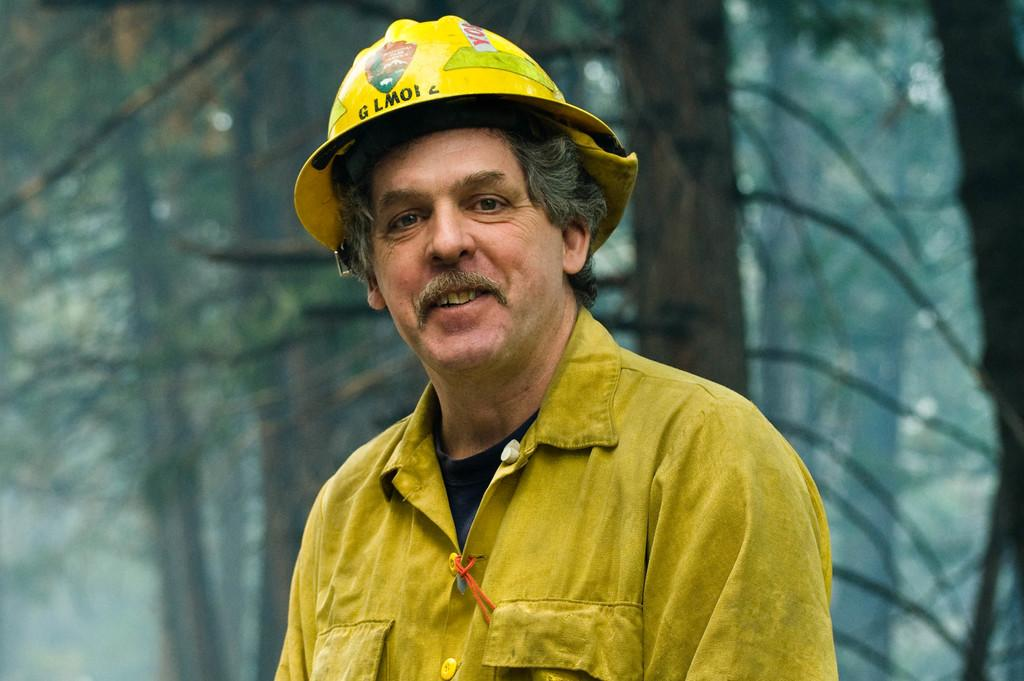What is the main subject of the image? The main subject of the image is a man. What is the man doing in the image? The man is smiling in the image. What can be seen in the background of the image? There are trees in the background of the image. What type of observation can be made about the coast in the image? There is no coast present in the image; it features a man smiling in front of trees. 